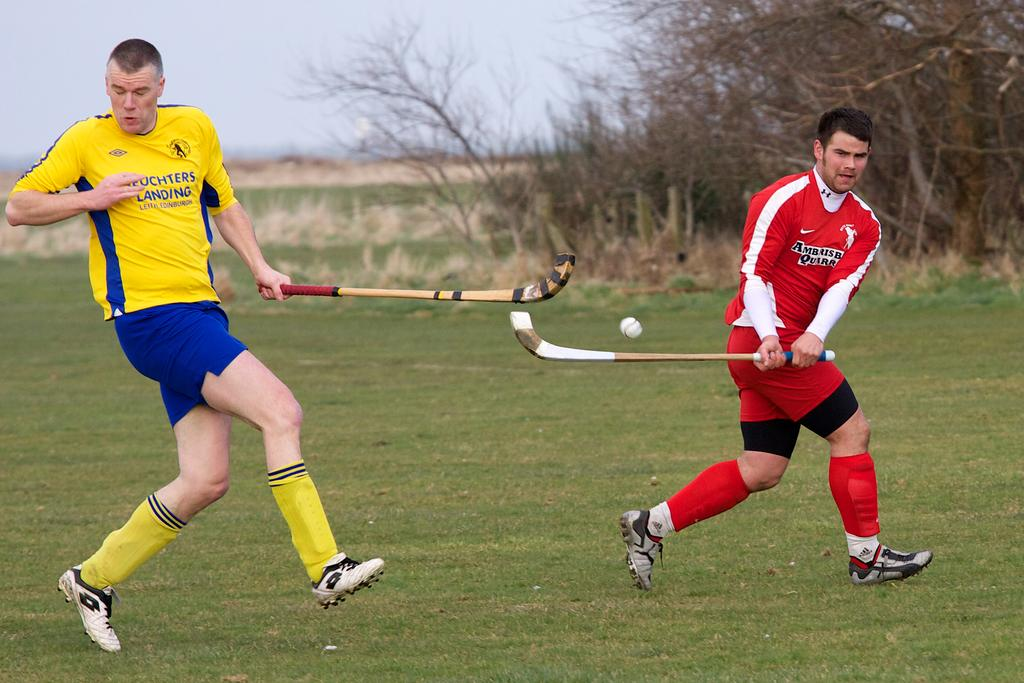What is the location of the image? The image is taken on a hockey ground. How many people are in the image? There are two persons in the image. What are the persons doing in the image? The persons are playing in the image. What can be seen in the background of the image? Trees and the sky are visible at the top of the image. What type of feather can be seen floating in the air in the image? There is no feather present in the image; it is taken on a hockey ground with people playing. 